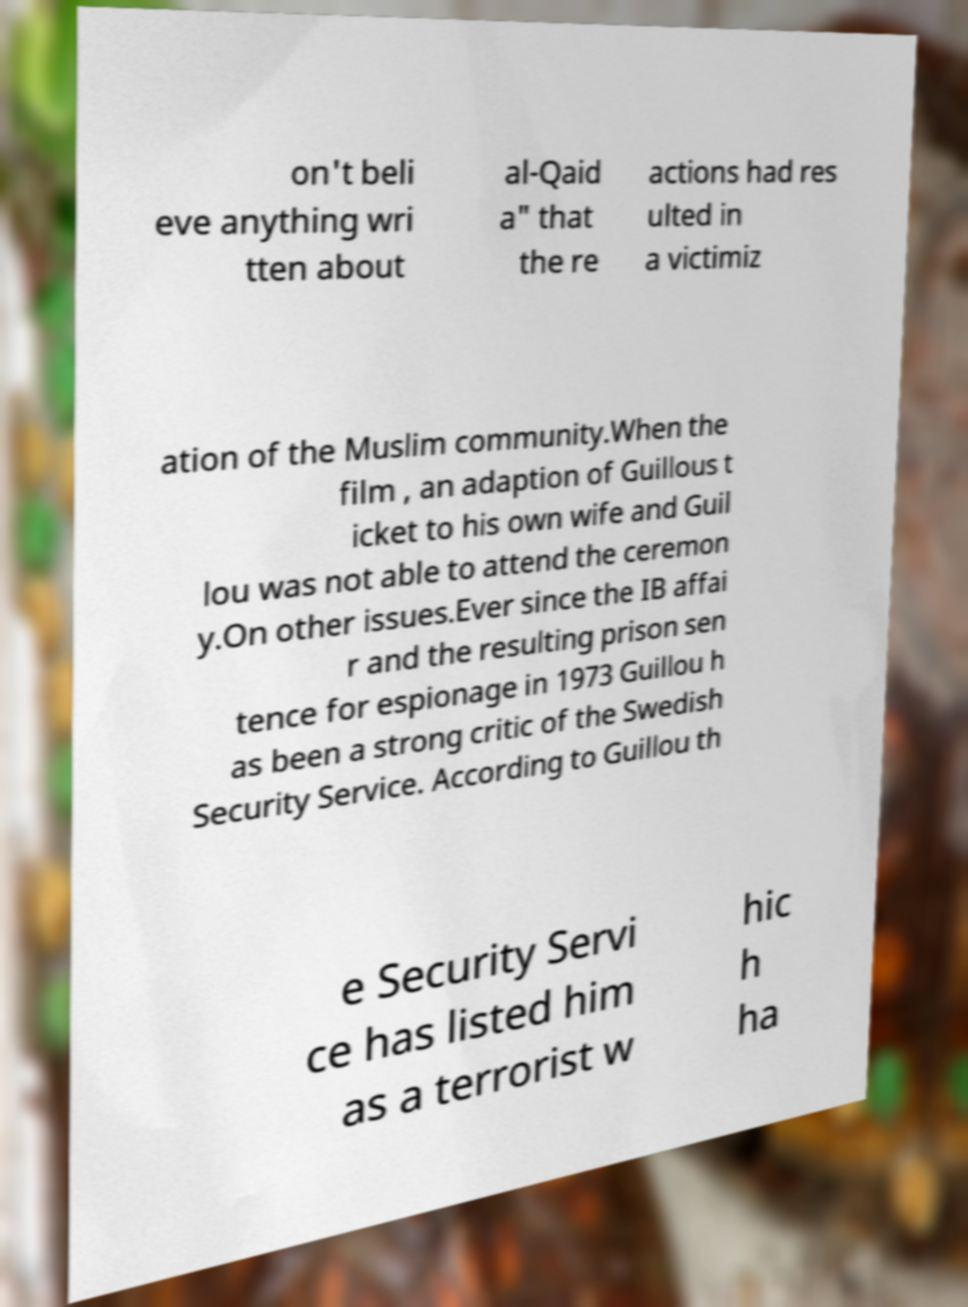Could you extract and type out the text from this image? on't beli eve anything wri tten about al-Qaid a" that the re actions had res ulted in a victimiz ation of the Muslim community.When the film , an adaption of Guillous t icket to his own wife and Guil lou was not able to attend the ceremon y.On other issues.Ever since the IB affai r and the resulting prison sen tence for espionage in 1973 Guillou h as been a strong critic of the Swedish Security Service. According to Guillou th e Security Servi ce has listed him as a terrorist w hic h ha 